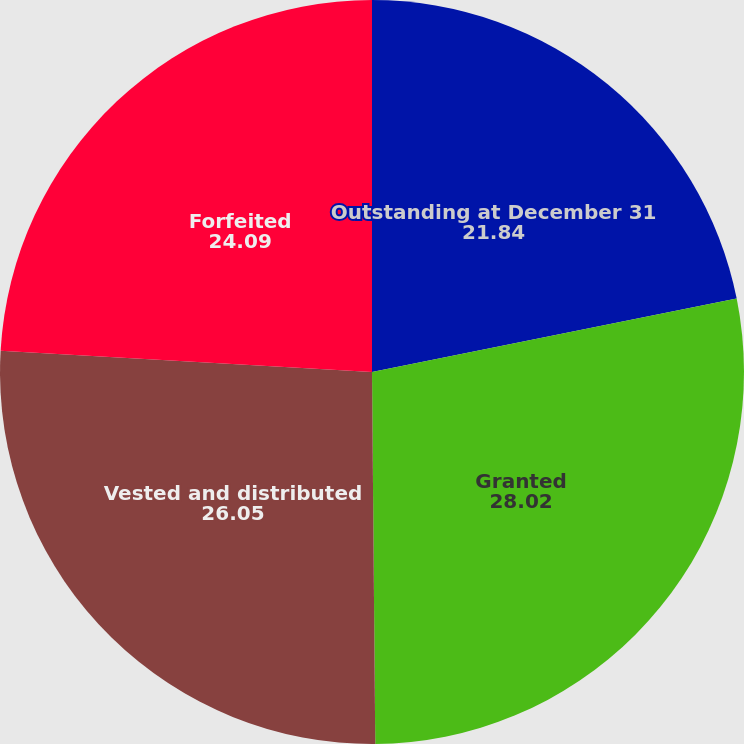Convert chart. <chart><loc_0><loc_0><loc_500><loc_500><pie_chart><fcel>Outstanding at December 31<fcel>Granted<fcel>Vested and distributed<fcel>Forfeited<nl><fcel>21.84%<fcel>28.02%<fcel>26.05%<fcel>24.09%<nl></chart> 